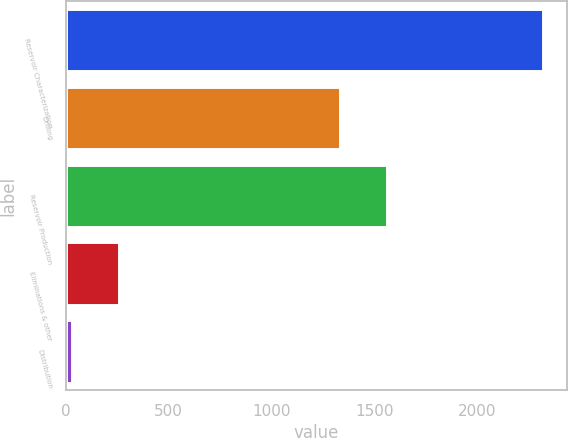Convert chart. <chart><loc_0><loc_0><loc_500><loc_500><bar_chart><fcel>Reservoir Characterization<fcel>Drilling<fcel>Reservoir Production<fcel>Eliminations & other<fcel>Distribution<nl><fcel>2321<fcel>1334<fcel>1563.2<fcel>258.2<fcel>29<nl></chart> 